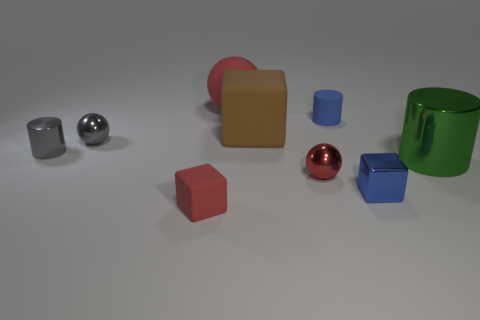Is there anything else that has the same color as the large rubber ball?
Offer a terse response. Yes. What number of big green cubes are there?
Provide a short and direct response. 0. There is a red thing behind the tiny cylinder on the right side of the small red matte cube; what is its material?
Give a very brief answer. Rubber. There is a metallic cylinder that is on the left side of the small cylinder that is on the right side of the tiny red thing that is left of the big block; what is its color?
Offer a very short reply. Gray. Does the matte cylinder have the same color as the tiny shiny block?
Ensure brevity in your answer.  Yes. What number of rubber objects have the same size as the gray metal cylinder?
Your answer should be compact. 2. Is the number of shiny cylinders that are in front of the blue block greater than the number of large brown things in front of the big green thing?
Provide a succinct answer. No. There is a tiny cylinder that is to the left of the tiny matte thing on the left side of the blue matte cylinder; what is its color?
Your response must be concise. Gray. Are the big green cylinder and the brown block made of the same material?
Your answer should be very brief. No. Are there any other matte objects of the same shape as the green thing?
Your response must be concise. Yes. 